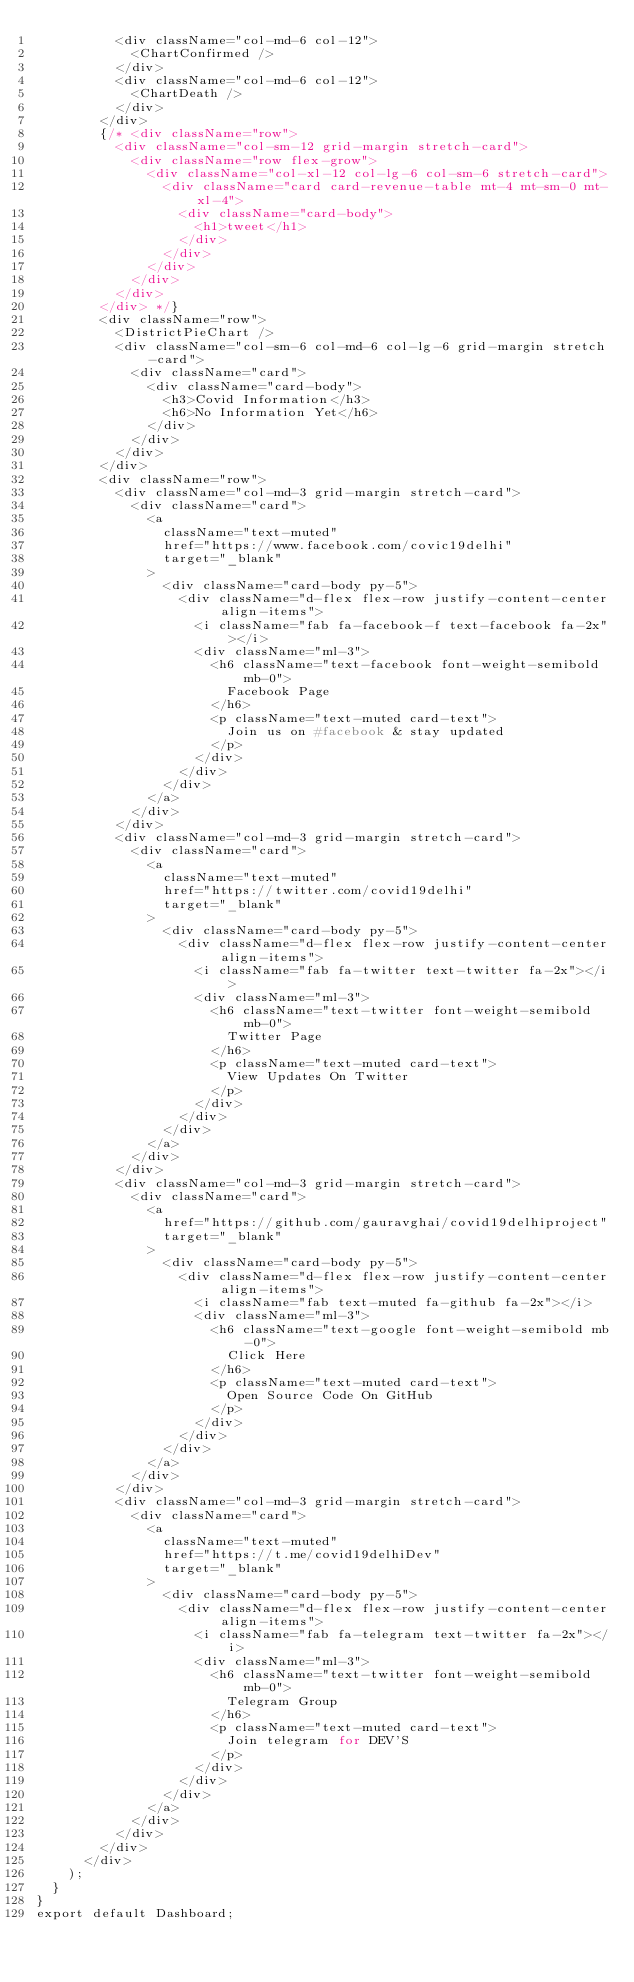<code> <loc_0><loc_0><loc_500><loc_500><_JavaScript_>          <div className="col-md-6 col-12">
            <ChartConfirmed />
          </div>
          <div className="col-md-6 col-12">
            <ChartDeath />
          </div>
        </div>
        {/* <div className="row">
          <div className="col-sm-12 grid-margin stretch-card">
            <div className="row flex-grow">
              <div className="col-xl-12 col-lg-6 col-sm-6 stretch-card">
                <div className="card card-revenue-table mt-4 mt-sm-0 mt-xl-4">
                  <div className="card-body">
                    <h1>tweet</h1>
                  </div>
                </div>
              </div>
            </div>
          </div>
        </div> */}
        <div className="row">
          <DistrictPieChart />
          <div className="col-sm-6 col-md-6 col-lg-6 grid-margin stretch-card">
            <div className="card">
              <div className="card-body">
                <h3>Covid Information</h3>
                <h6>No Information Yet</h6>
              </div>
            </div>
          </div>
        </div>
        <div className="row">
          <div className="col-md-3 grid-margin stretch-card">
            <div className="card">
              <a
                className="text-muted"
                href="https://www.facebook.com/covic19delhi"
                target="_blank"
              >
                <div className="card-body py-5">
                  <div className="d-flex flex-row justify-content-center align-items">
                    <i className="fab fa-facebook-f text-facebook fa-2x"></i>
                    <div className="ml-3">
                      <h6 className="text-facebook font-weight-semibold mb-0">
                        Facebook Page
                      </h6>
                      <p className="text-muted card-text">
                        Join us on #facebook & stay updated
                      </p>
                    </div>
                  </div>
                </div>
              </a>
            </div>
          </div>
          <div className="col-md-3 grid-margin stretch-card">
            <div className="card">
              <a
                className="text-muted"
                href="https://twitter.com/covid19delhi"
                target="_blank"
              >
                <div className="card-body py-5">
                  <div className="d-flex flex-row justify-content-center align-items">
                    <i className="fab fa-twitter text-twitter fa-2x"></i>
                    <div className="ml-3">
                      <h6 className="text-twitter font-weight-semibold mb-0">
                        Twitter Page
                      </h6>
                      <p className="text-muted card-text">
                        View Updates On Twitter
                      </p>
                    </div>
                  </div>
                </div>
              </a>
            </div>
          </div>
          <div className="col-md-3 grid-margin stretch-card">
            <div className="card">
              <a
                href="https://github.com/gauravghai/covid19delhiproject"
                target="_blank"
              >
                <div className="card-body py-5">
                  <div className="d-flex flex-row justify-content-center align-items">
                    <i className="fab text-muted fa-github fa-2x"></i>
                    <div className="ml-3">
                      <h6 className="text-google font-weight-semibold mb-0">
                        Click Here
                      </h6>
                      <p className="text-muted card-text">
                        Open Source Code On GitHub
                      </p>
                    </div>
                  </div>
                </div>
              </a>
            </div>
          </div>
          <div className="col-md-3 grid-margin stretch-card">
            <div className="card">
              <a
                className="text-muted"
                href="https://t.me/covid19delhiDev"
                target="_blank"
              >
                <div className="card-body py-5">
                  <div className="d-flex flex-row justify-content-center align-items">
                    <i className="fab fa-telegram text-twitter fa-2x"></i>
                    <div className="ml-3">
                      <h6 className="text-twitter font-weight-semibold mb-0">
                        Telegram Group
                      </h6>
                      <p className="text-muted card-text">
                        Join telegram for DEV'S
                      </p>
                    </div>
                  </div>
                </div>
              </a>
            </div>
          </div>
        </div>
      </div>
    );
  }
}
export default Dashboard;
</code> 